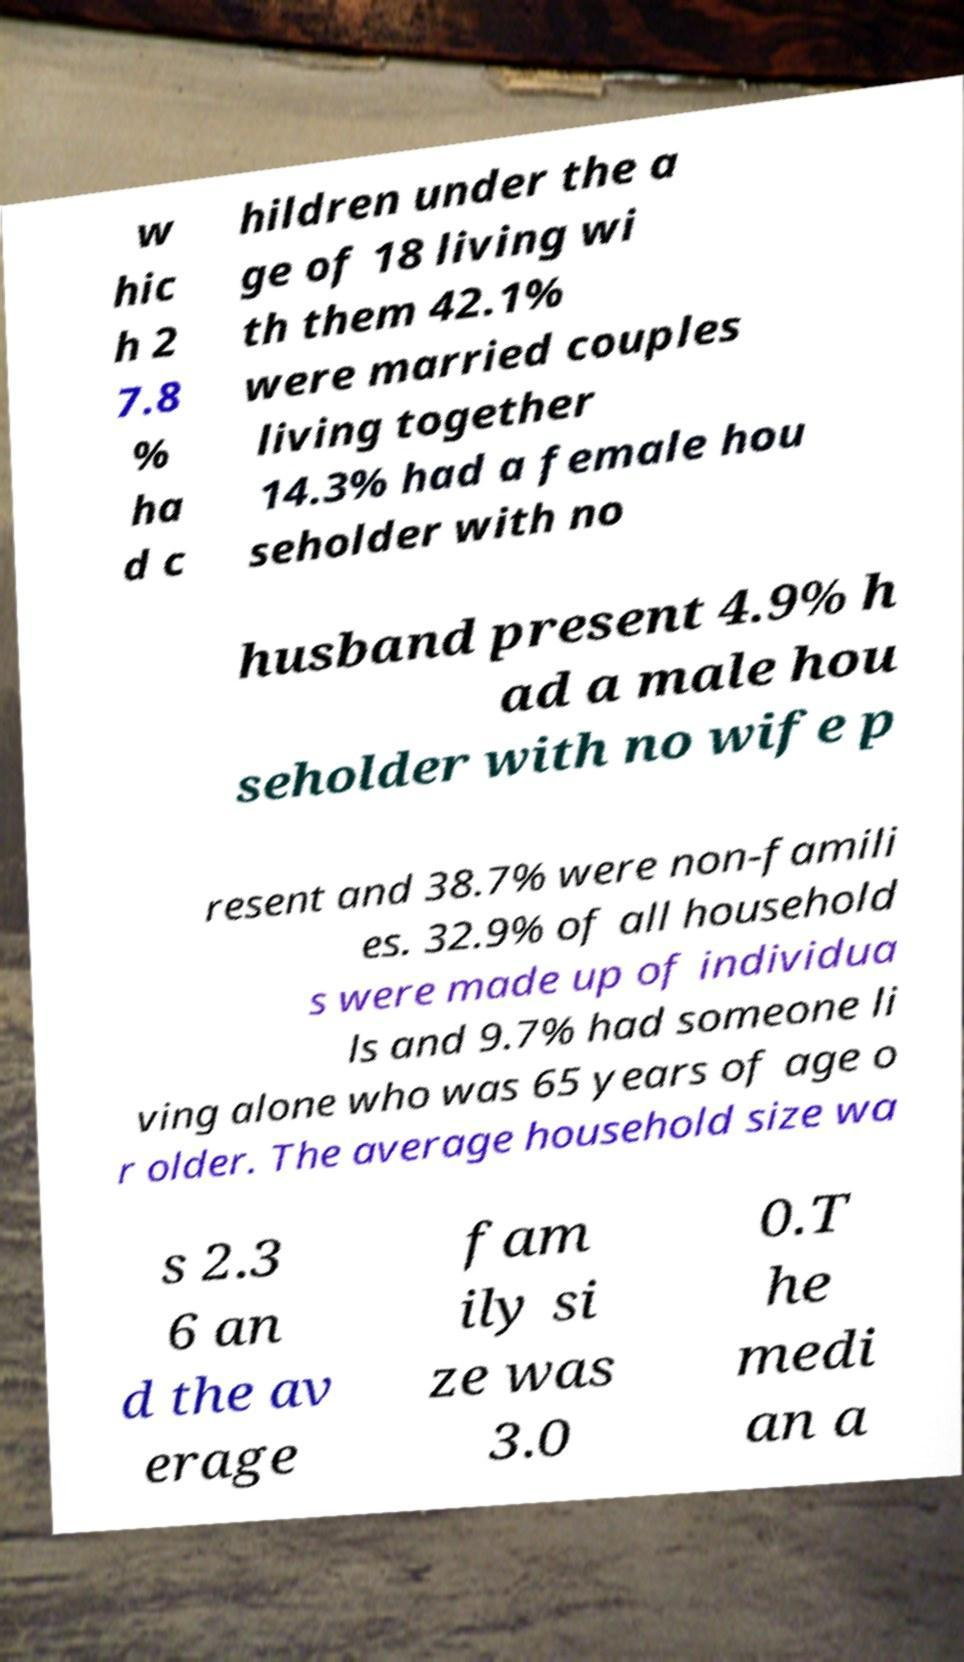Please read and relay the text visible in this image. What does it say? w hic h 2 7.8 % ha d c hildren under the a ge of 18 living wi th them 42.1% were married couples living together 14.3% had a female hou seholder with no husband present 4.9% h ad a male hou seholder with no wife p resent and 38.7% were non-famili es. 32.9% of all household s were made up of individua ls and 9.7% had someone li ving alone who was 65 years of age o r older. The average household size wa s 2.3 6 an d the av erage fam ily si ze was 3.0 0.T he medi an a 